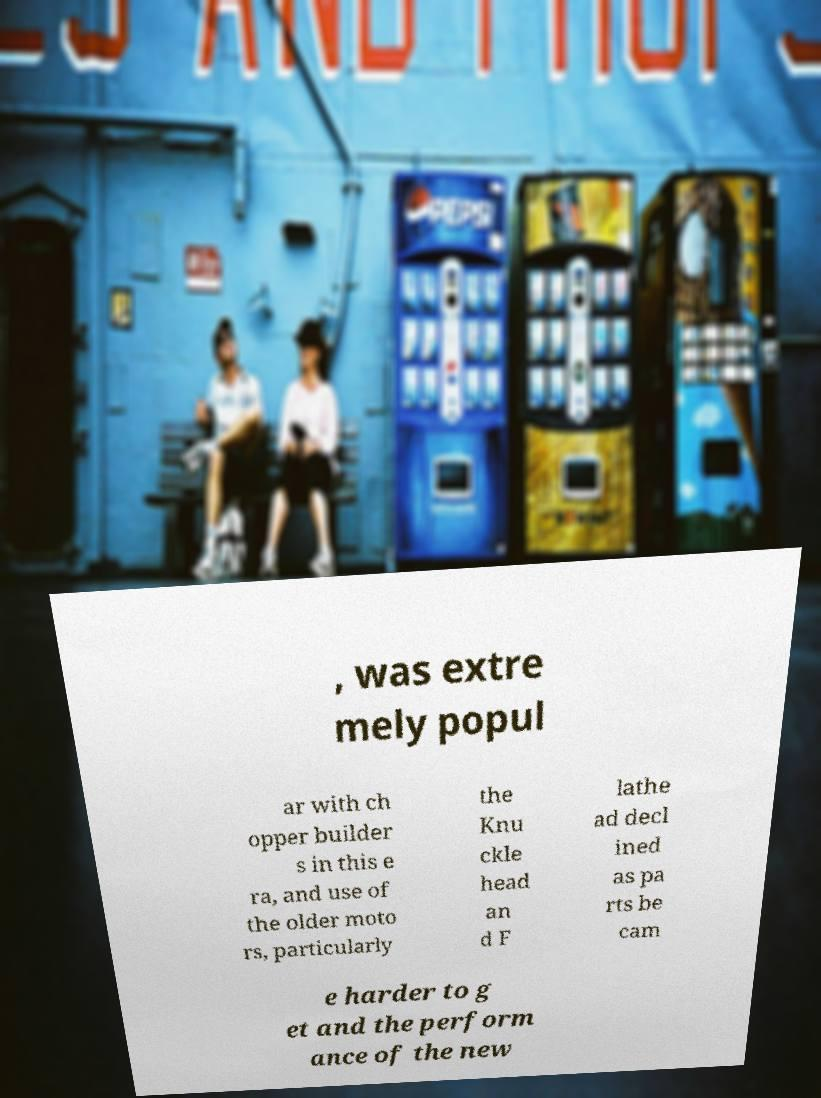Please read and relay the text visible in this image. What does it say? , was extre mely popul ar with ch opper builder s in this e ra, and use of the older moto rs, particularly the Knu ckle head an d F lathe ad decl ined as pa rts be cam e harder to g et and the perform ance of the new 